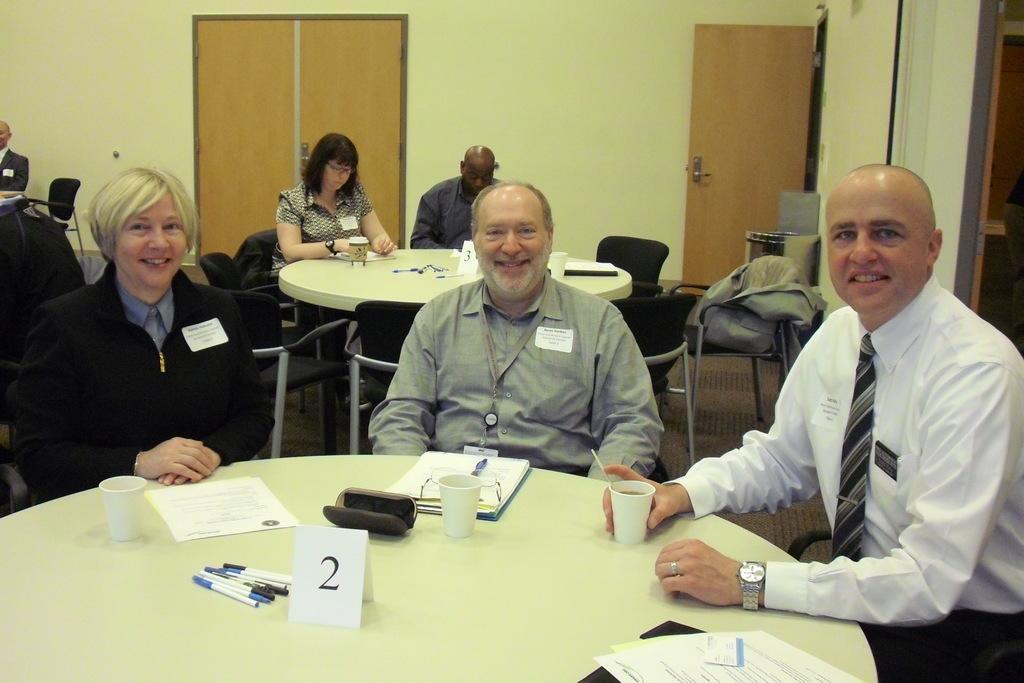Please provide a concise description of this image. At the bottom of the image there is a table, on the table there are some papers and pens and cups. Behind the table few people are sitting and smiling. Behind them there are some chairs and few people are sitting and there are some tables, on the tables there are some cups and pens and papers. At the top of the image there is wall, on the wall there is a door. 